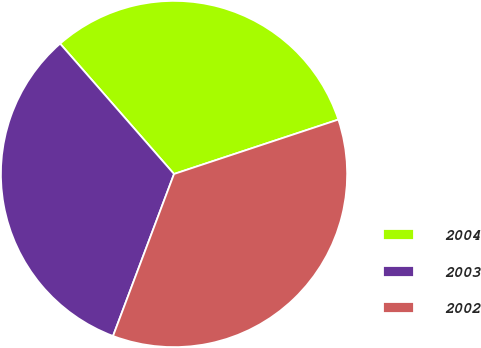Convert chart. <chart><loc_0><loc_0><loc_500><loc_500><pie_chart><fcel>2004<fcel>2003<fcel>2002<nl><fcel>31.34%<fcel>32.84%<fcel>35.82%<nl></chart> 